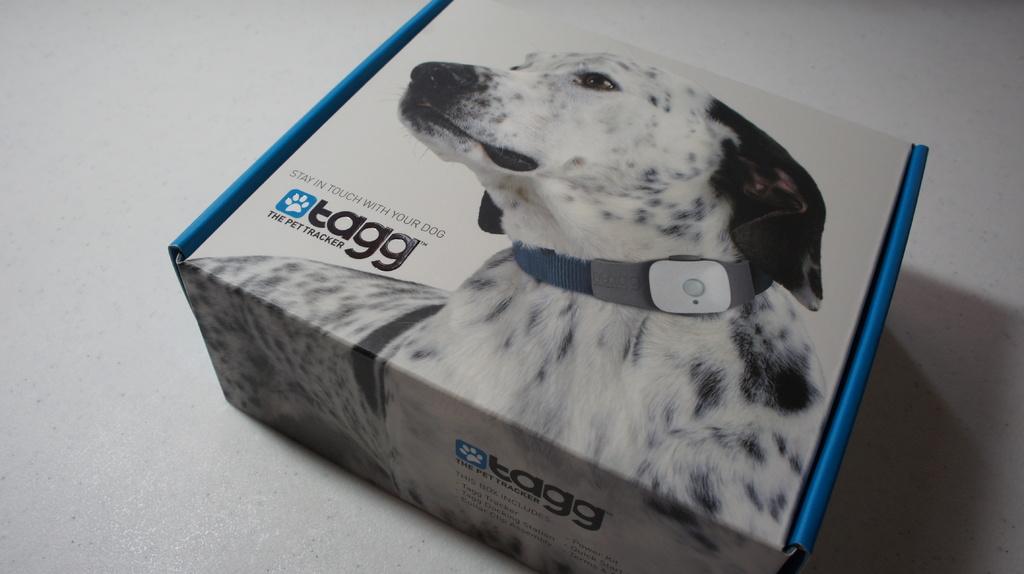What is this product used for?
Ensure brevity in your answer.  Pet tracker. What is the brand name?
Your answer should be compact. Tagg. 